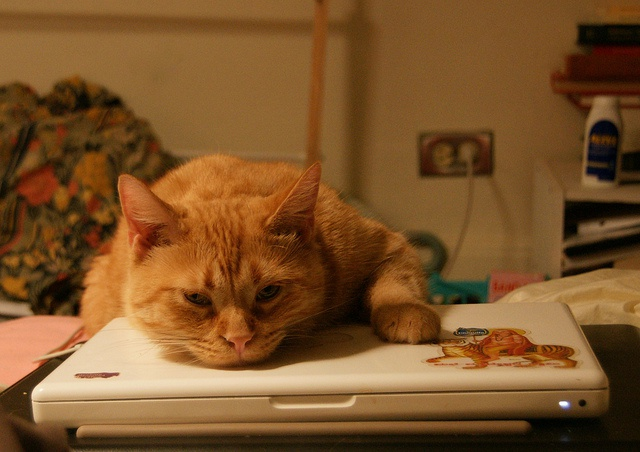Describe the objects in this image and their specific colors. I can see laptop in olive, brown, tan, and maroon tones, cat in olive, brown, maroon, black, and orange tones, bottle in olive, black, maroon, and gray tones, book in maroon and olive tones, and book in black, maroon, and olive tones in this image. 